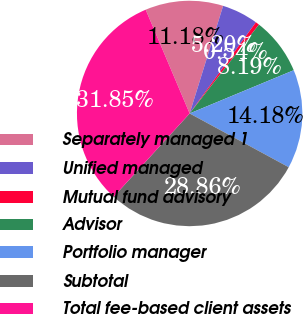<chart> <loc_0><loc_0><loc_500><loc_500><pie_chart><fcel>Separately managed 1<fcel>Unified managed<fcel>Mutual fund advisory<fcel>Advisor<fcel>Portfolio manager<fcel>Subtotal<fcel>Total fee-based client assets<nl><fcel>11.18%<fcel>5.2%<fcel>0.54%<fcel>8.19%<fcel>14.18%<fcel>28.86%<fcel>31.85%<nl></chart> 